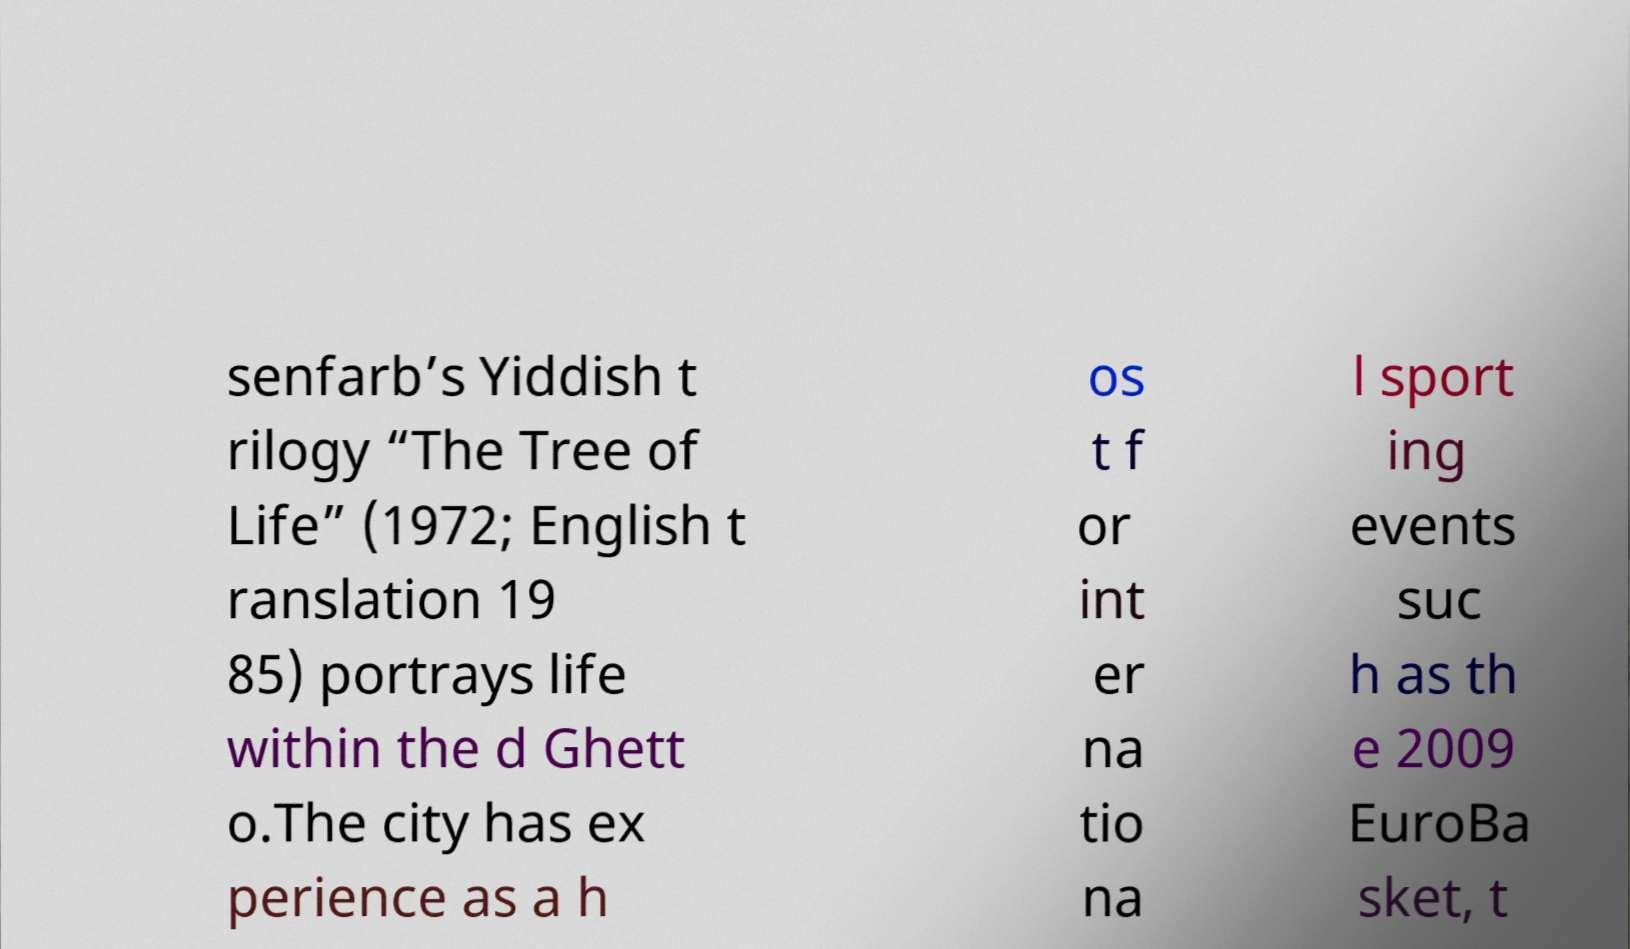I need the written content from this picture converted into text. Can you do that? senfarb’s Yiddish t rilogy “The Tree of Life” (1972; English t ranslation 19 85) portrays life within the d Ghett o.The city has ex perience as a h os t f or int er na tio na l sport ing events suc h as th e 2009 EuroBa sket, t 